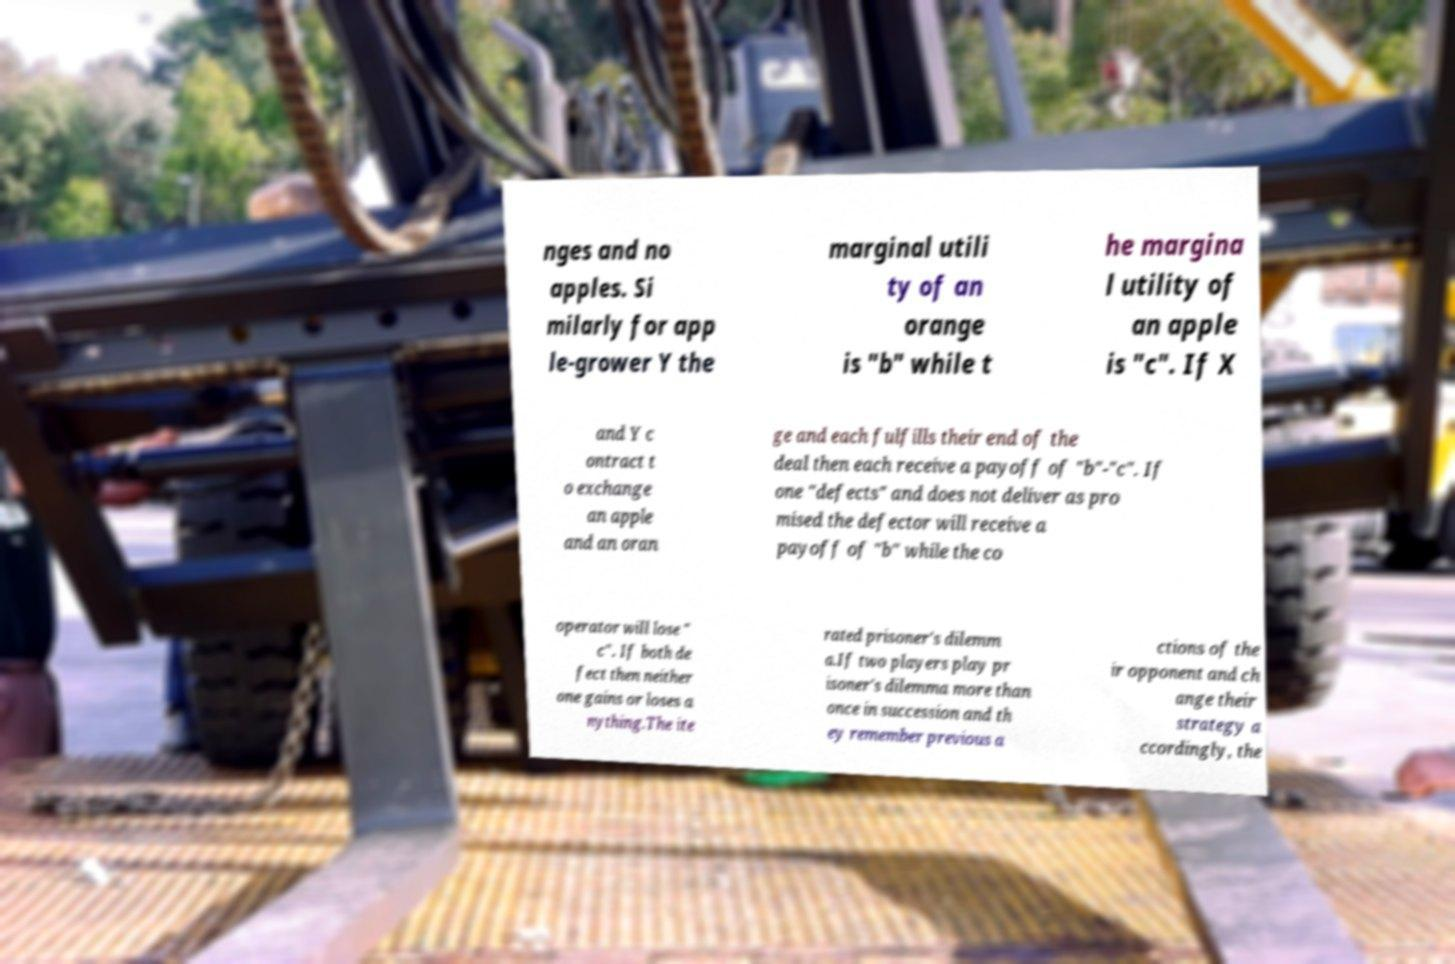I need the written content from this picture converted into text. Can you do that? nges and no apples. Si milarly for app le-grower Y the marginal utili ty of an orange is "b" while t he margina l utility of an apple is "c". If X and Y c ontract t o exchange an apple and an oran ge and each fulfills their end of the deal then each receive a payoff of "b"-"c". If one "defects" and does not deliver as pro mised the defector will receive a payoff of "b" while the co operator will lose " c". If both de fect then neither one gains or loses a nything.The ite rated prisoner's dilemm a.If two players play pr isoner's dilemma more than once in succession and th ey remember previous a ctions of the ir opponent and ch ange their strategy a ccordingly, the 